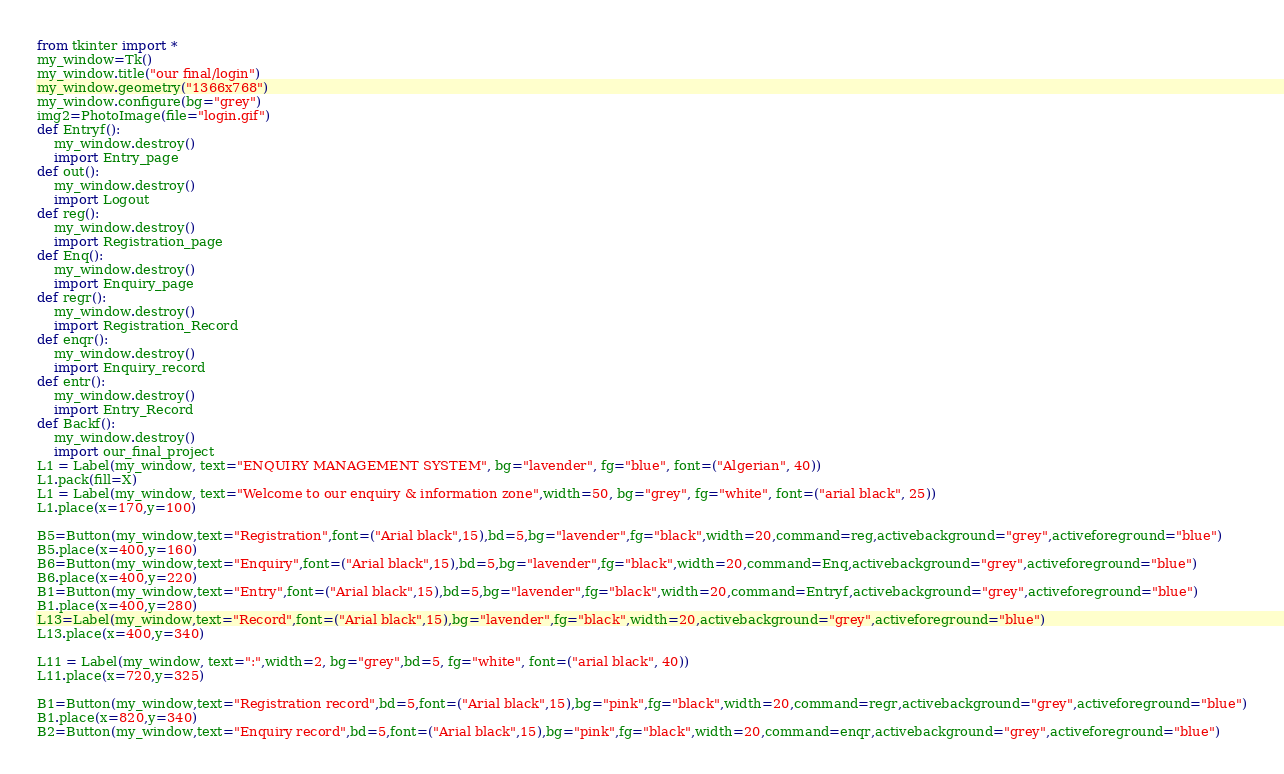Convert code to text. <code><loc_0><loc_0><loc_500><loc_500><_Python_>from tkinter import *
my_window=Tk()
my_window.title("our final/login")
my_window.geometry("1366x768")
my_window.configure(bg="grey")
img2=PhotoImage(file="login.gif")
def Entryf():
    my_window.destroy()
    import Entry_page
def out():
    my_window.destroy()
    import Logout
def reg():
    my_window.destroy()
    import Registration_page
def Enq():
    my_window.destroy()
    import Enquiry_page
def regr():
    my_window.destroy()
    import Registration_Record
def enqr():
    my_window.destroy()
    import Enquiry_record
def entr():
    my_window.destroy()
    import Entry_Record
def Backf():
    my_window.destroy()
    import our_final_project
L1 = Label(my_window, text="ENQUIRY MANAGEMENT SYSTEM", bg="lavender", fg="blue", font=("Algerian", 40))
L1.pack(fill=X)
L1 = Label(my_window, text="Welcome to our enquiry & information zone",width=50, bg="grey", fg="white", font=("arial black", 25))
L1.place(x=170,y=100)

B5=Button(my_window,text="Registration",font=("Arial black",15),bd=5,bg="lavender",fg="black",width=20,command=reg,activebackground="grey",activeforeground="blue")
B5.place(x=400,y=160)
B6=Button(my_window,text="Enquiry",font=("Arial black",15),bd=5,bg="lavender",fg="black",width=20,command=Enq,activebackground="grey",activeforeground="blue")
B6.place(x=400,y=220)
B1=Button(my_window,text="Entry",font=("Arial black",15),bd=5,bg="lavender",fg="black",width=20,command=Entryf,activebackground="grey",activeforeground="blue")
B1.place(x=400,y=280)
L13=Label(my_window,text="Record",font=("Arial black",15),bg="lavender",fg="black",width=20,activebackground="grey",activeforeground="blue")
L13.place(x=400,y=340)

L11 = Label(my_window, text=":",width=2, bg="grey",bd=5, fg="white", font=("arial black", 40))
L11.place(x=720,y=325)

B1=Button(my_window,text="Registration record",bd=5,font=("Arial black",15),bg="pink",fg="black",width=20,command=regr,activebackground="grey",activeforeground="blue")
B1.place(x=820,y=340)
B2=Button(my_window,text="Enquiry record",bd=5,font=("Arial black",15),bg="pink",fg="black",width=20,command=enqr,activebackground="grey",activeforeground="blue")</code> 